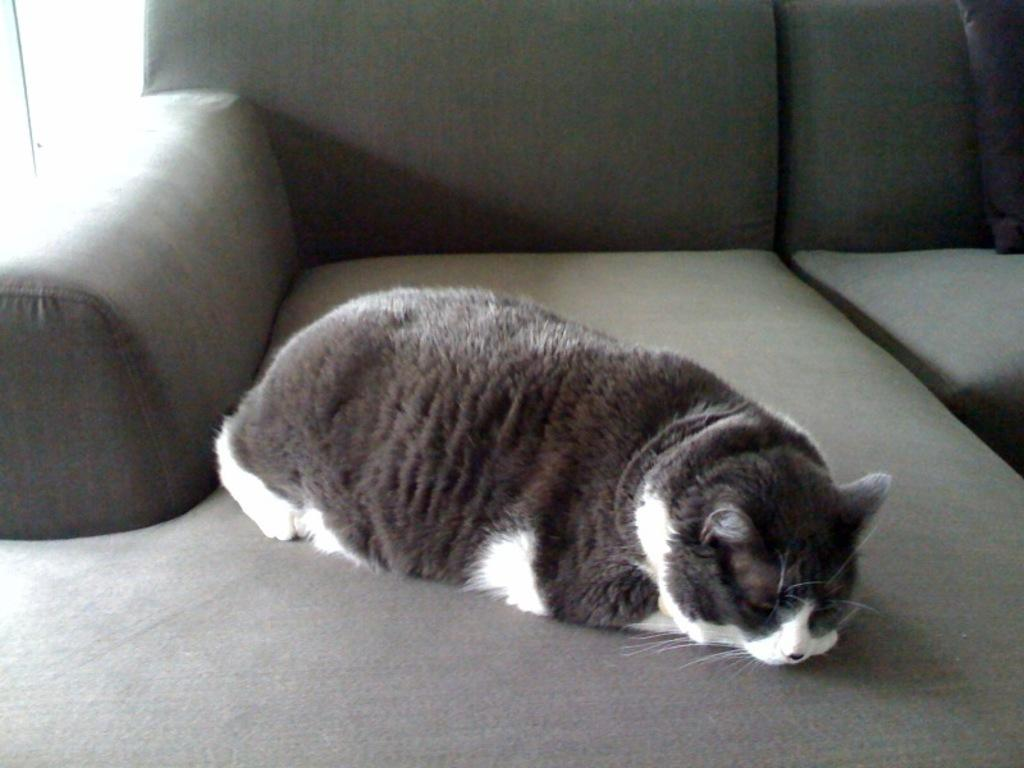What type of furniture is present in the image? There is a sofa in the image. What is on the sofa? A cat is sleeping on the sofa. Can you describe the appearance of the cat? The cat is black and white in color. What type of meat is the cat eating in the image? There is no meat present in the image; the cat is sleeping on the sofa. 